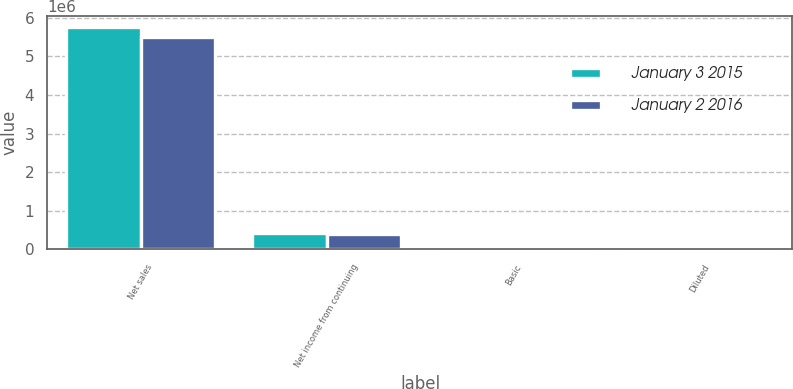<chart> <loc_0><loc_0><loc_500><loc_500><stacked_bar_chart><ecel><fcel>Net sales<fcel>Net income from continuing<fcel>Basic<fcel>Diluted<nl><fcel>January 3 2015<fcel>5.75371e+06<fcel>433636<fcel>1.08<fcel>1.07<nl><fcel>January 2 2016<fcel>5.49086e+06<fcel>404973<fcel>1.01<fcel>0.99<nl></chart> 